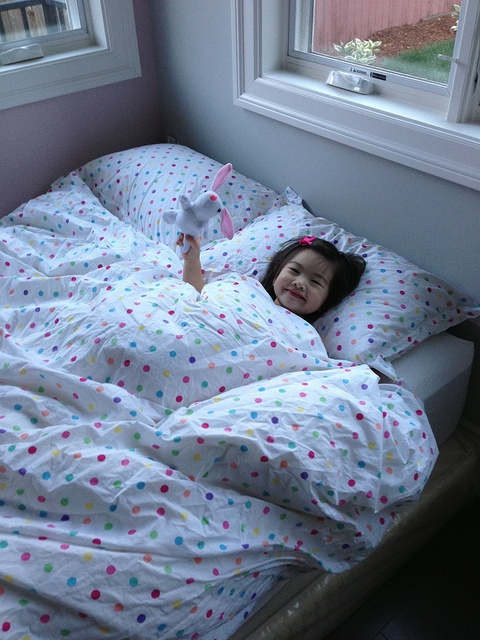Describe the objects in this image and their specific colors. I can see bed in gray, darkgray, and lightblue tones, people in gray, black, and lightblue tones, and potted plant in gray, darkgray, lightgray, and lightblue tones in this image. 